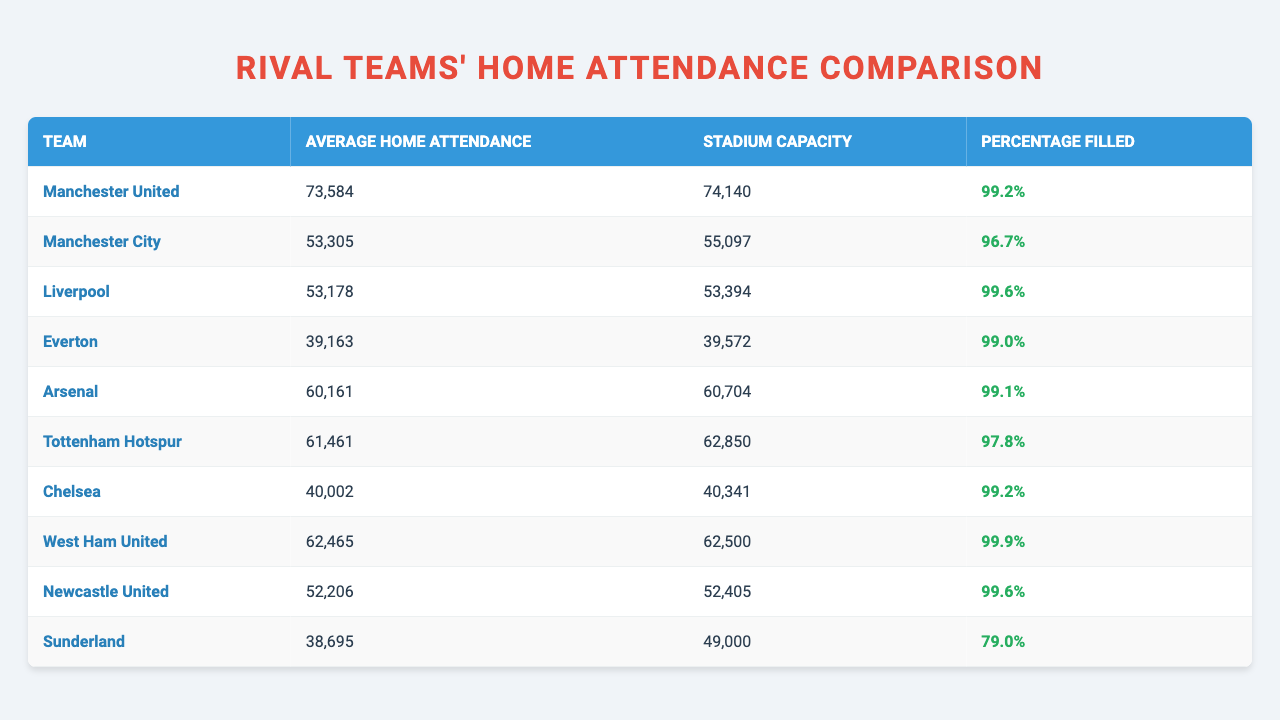What is the average home attendance for Liverpool? The table states that Liverpool's average home attendance is listed as 53,178.
Answer: 53,178 Which team has the highest average home attendance this season? According to the table, Manchester United has the highest average home attendance at 73,584.
Answer: Manchester United What percentage of Manchester City’s stadium was filled during home games? The table indicates that Manchester City had a stadium filled to 96.7% of its capacity.
Answer: 96.7% How does Chelsea's average home attendance compare to Everton's? Chelsea has an average home attendance of 40,002, while Everton's is 39,163, making Chelsea's attendance higher by 839.
Answer: Higher by 839 Which team has the lowest average home attendance? The table shows Sunderland has the lowest average home attendance with 38,695.
Answer: Sunderland What is the total average home attendance of Arsenal and Tottenham Hotspur combined? Arsenal's average home attendance is 60,161 and Tottenham Hotspur's is 61,461. Adding these gives 121,622.
Answer: 121,622 Is West Ham United's average home attendance more than 62,000? The table shows West Ham United's average home attendance is 62,465, which is indeed more than 62,000.
Answer: Yes Which team filled their stadium closest to capacity? West Ham United's stadium was filled to 99.9% of its capacity, which is the highest percentage in the table.
Answer: West Ham United How many teams have an average home attendance above 50,000? From the data, the teams above 50,000 are Manchester United, Manchester City, Liverpool, Arsenal, and Tottenham Hotspur, totaling five teams.
Answer: 5 What is the percentage difference in average home attendance between Manchester United and Sunderland? Manchester United's average is 73,584 and Sunderland's is 38,695. The difference is 34,889, and the percentage difference based on Sunderland's attendance is approximately 90.2%.
Answer: 90.2% 